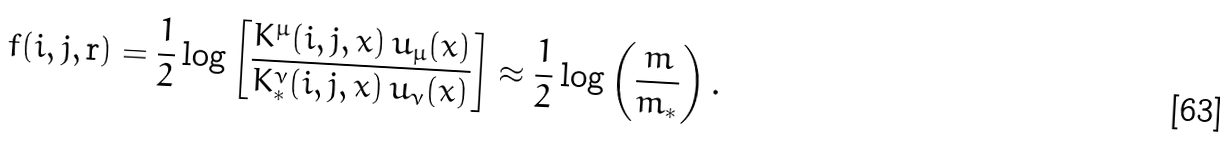<formula> <loc_0><loc_0><loc_500><loc_500>f ( i , j , { \mathbf r } ) = \frac { 1 } { 2 } \log \left [ \frac { K ^ { \mu } ( i , j , x ) \, u _ { \mu } ( x ) } { K ^ { \nu } _ { * } ( i , j , x ) \, u _ { \nu } ( x ) } \right ] \approx \frac { 1 } { 2 } \log \left ( \frac { m } { m _ { * } } \right ) .</formula> 